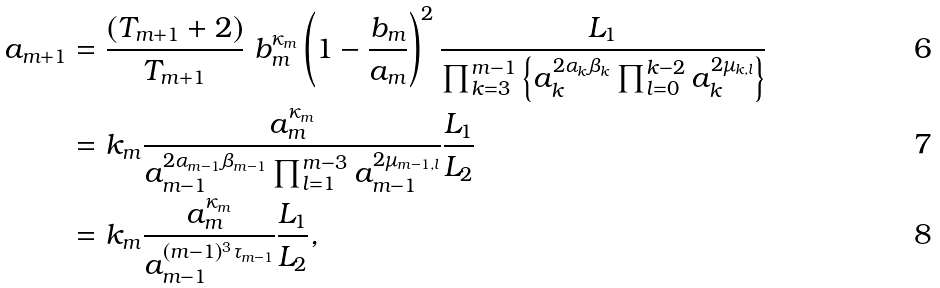Convert formula to latex. <formula><loc_0><loc_0><loc_500><loc_500>a _ { m + 1 } & = \frac { ( T _ { m + 1 } + 2 ) } { T _ { m + 1 } } \ b _ { m } ^ { \kappa _ { m } } \left ( 1 - \frac { b _ { m } } { a _ { m } } \right ) ^ { 2 } \frac { L _ { 1 } } { \prod _ { k = 3 } ^ { m - 1 } \left \{ a _ { k } ^ { 2 \alpha _ { k } \beta _ { k } } \prod _ { l = 0 } ^ { k - 2 } a _ { k } ^ { 2 \mu _ { k , l } } \right \} } \\ & = k _ { m } \frac { a _ { m } ^ { \kappa _ { m } } } { a _ { m - 1 } ^ { 2 \alpha _ { m - 1 } \beta _ { m - 1 } } \prod _ { l = 1 } ^ { m - 3 } a _ { m - 1 } ^ { 2 \mu _ { m - 1 , l } } } \frac { L _ { 1 } } { L _ { 2 } } \\ & = k _ { m } \frac { a _ { m } ^ { \kappa _ { m } } } { a _ { m - 1 } ^ { ( m - 1 ) ^ { 3 } \tau _ { m - 1 } } } \frac { L _ { 1 } } { L _ { 2 } } ,</formula> 